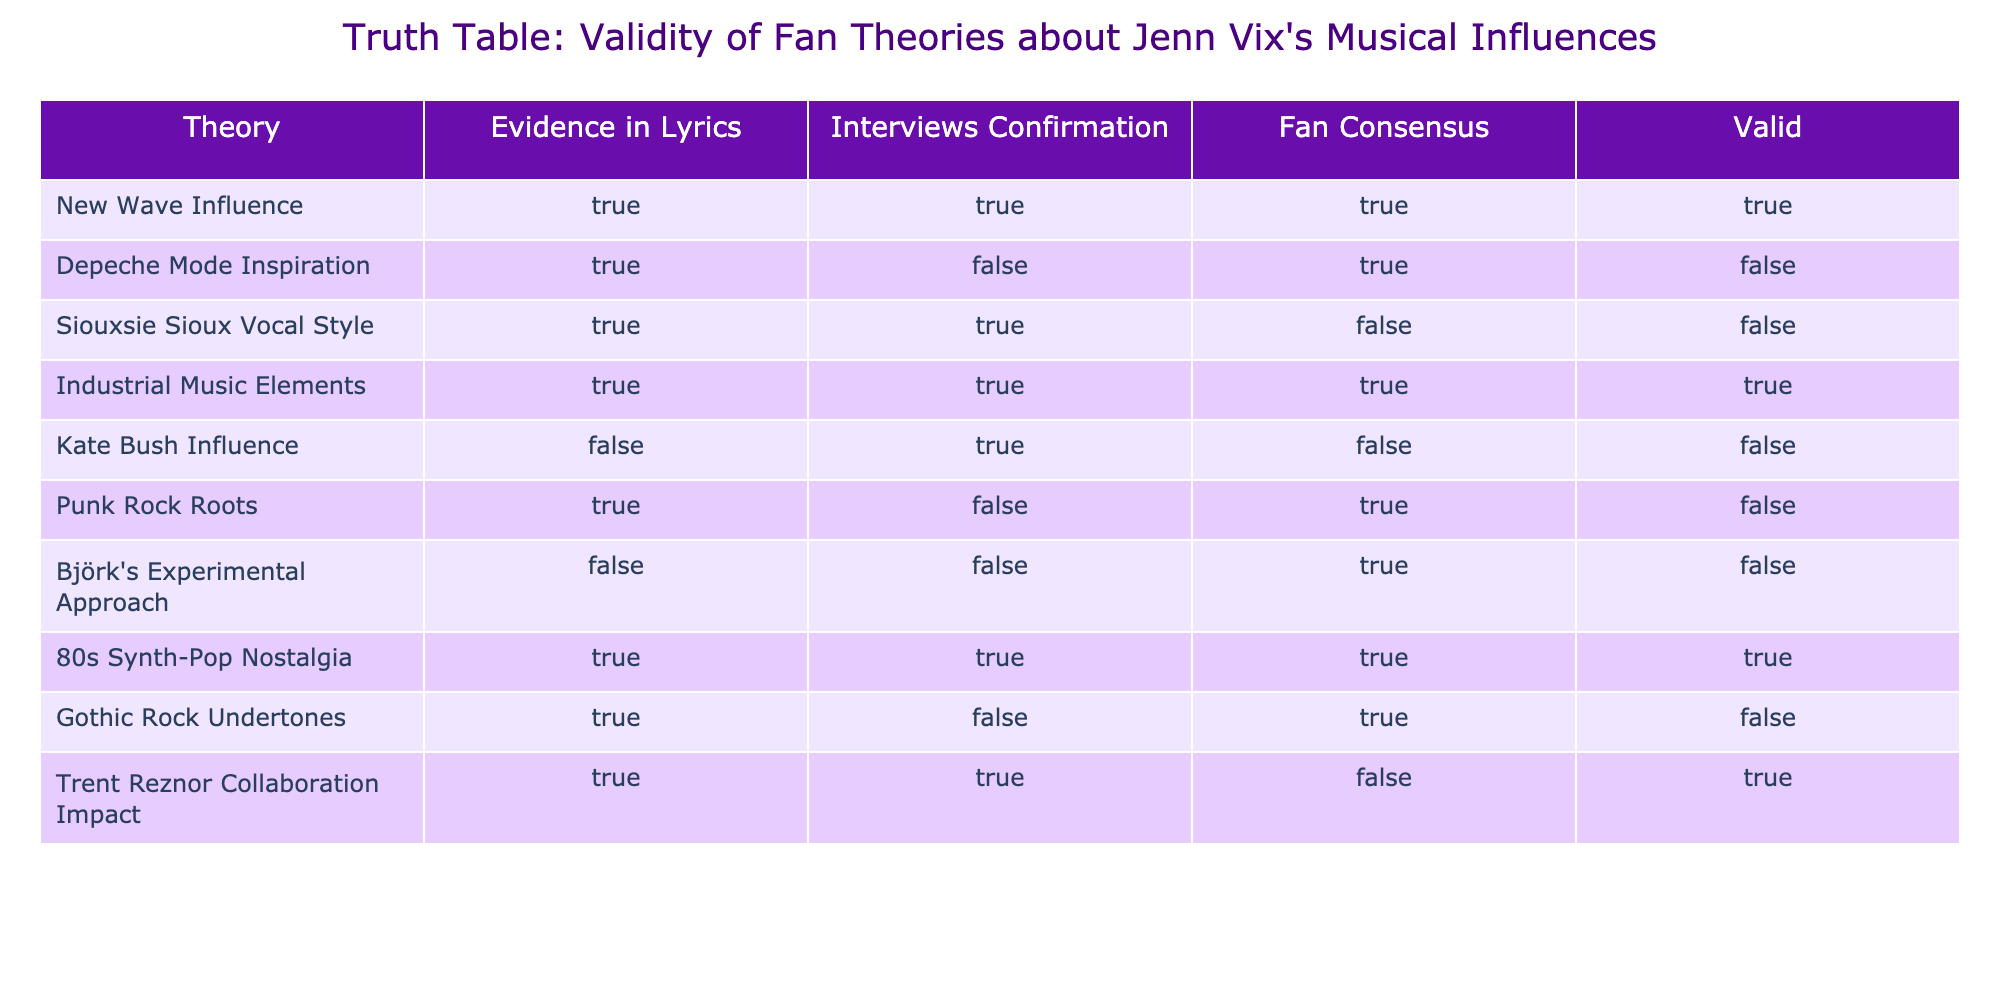What theories have confirmed evidence in both lyrics and interviews? To find the theories that have confirmed evidence in both categories, we look for rows where both "Evidence in Lyrics" and "Interviews Confirmation" are marked TRUE. Checking the table, the theories that fit this description are "New Wave Influence," "Industrial Music Elements," and "80s Synth-Pop Nostalgia."
Answer: New Wave Influence, Industrial Music Elements, 80s Synth-Pop Nostalgia Is there a theory that has true evidence in lyrics but false confirmation in interviews and is still considered valid? The table shows many theories with true evidence in lyrics and false confirmation in interviews. To check if they are valid, we examine rows that have "TRUE" in "Evidence in Lyrics," "FALSE" in "Interviews Confirmation," and "TRUE" in "Valid." The only theory that meets this requirement is "Trent Reznor Collaboration Impact."
Answer: Yes, Trent Reznor Collaboration Impact How many total theories are marked as valid? To find the total valid theories, we count the rows where "Valid" is TRUE. In the table, the "Valid" column shows TRUE for four theories: "New Wave Influence," "Industrial Music Elements," "80s Synth-Pop Nostalgia," and "Trent Reznor Collaboration Impact." Therefore, 4 theories are valid.
Answer: 4 Which theory has the lowest consensus among fans? To find out which theory has the lowest fan consensus, we look for rows with the lowest "Fan Consensus" that is true. In the table, "Siouxsie Sioux Vocal Style," "Kate Bush Influence," and "Gothic Rock Undertones" have false consensus. Among these, "Kate Bush Influence" is noted as having a fan consensus that is also false. Thus, it has the lowest, or no consensus.
Answer: Kate Bush Influence Are there any theories that are valid despite false confirmation in interviews? The table shows that "New Wave Influence," "Industrial Music Elements," "80s Synth-Pop Nostalgia," and "Trent Reznor Collaboration Impact" are marked as valid. Out of these, "Trent Reznor Collaboration Impact" has true evidence in both categories but false fan consensus. Thus we can say yes, this theory is valid despite false confirmation in interviews.
Answer: Yes, Trent Reznor Collaboration Impact 